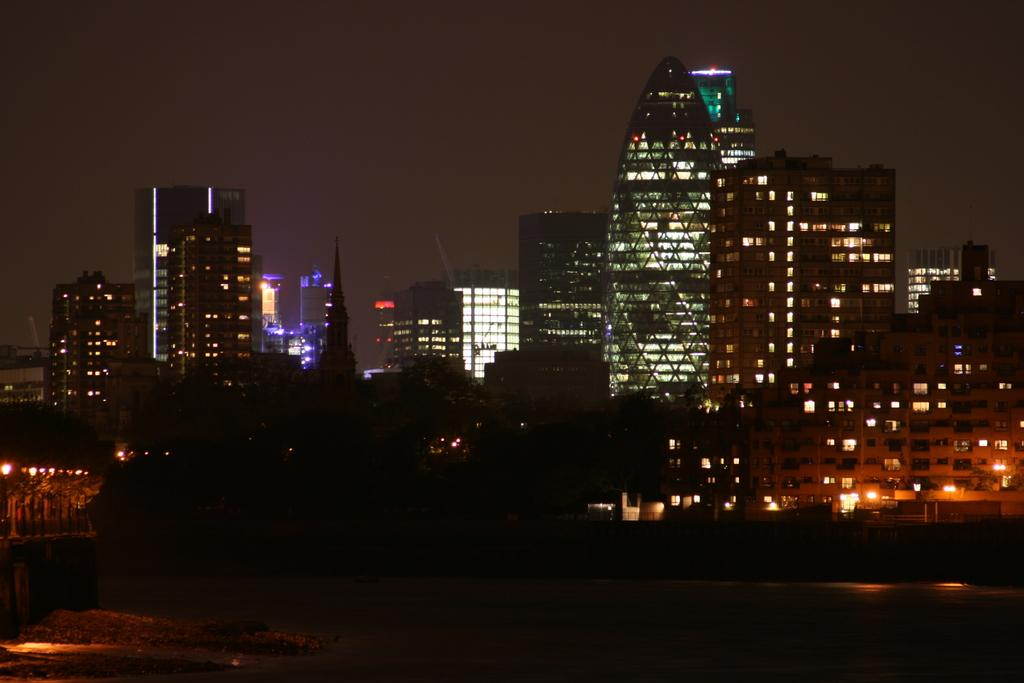What type of structures can be seen in the image? There are buildings in the image. What else is visible in the image besides the buildings? There are lights in the image. Can you describe the overall lighting in the image? The image appears to be slightly dark. What type of hat is the cent wearing in the image? There is no cent or hat present in the image. 